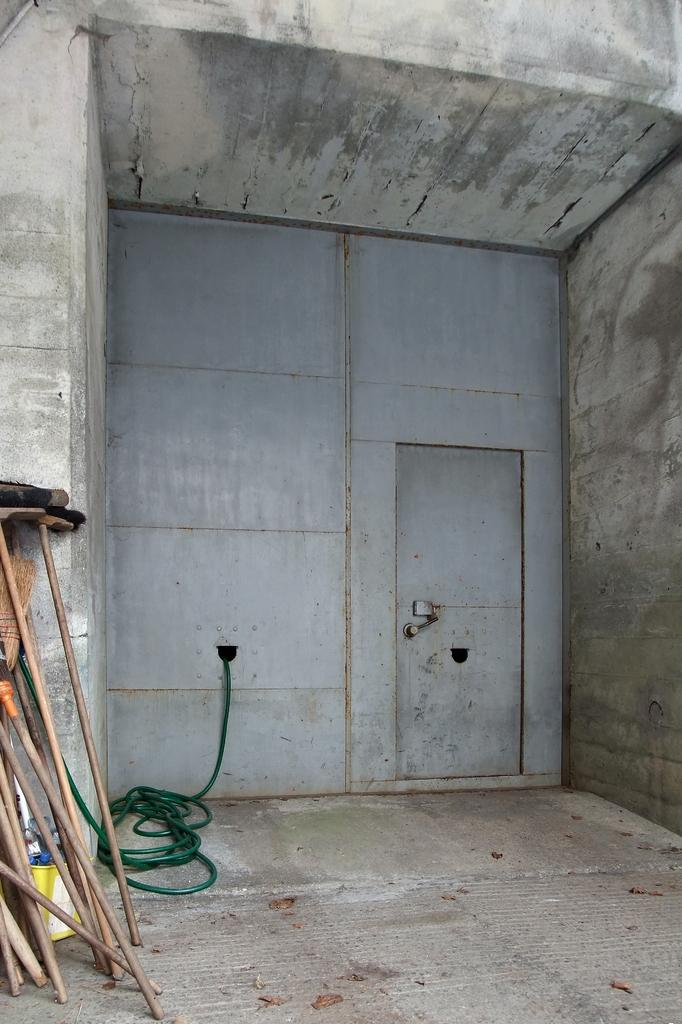What type of objects can be seen in the image? There are sticks, a pipe, and other objects in the image. Can you describe the structure in the image? There is a door and a wall in the image, which suggests a room or enclosed space. What is at the bottom of the image? There is a floor at the bottom of the image. What type of stew is being cooked in the image? There is no stew present in the image; it features sticks, a pipe, and other objects in a room or enclosed space. Can you describe the locket that is hanging from the pipe in the image? There is no locket hanging from the pipe in the image; only the pipe and other objects are present. 